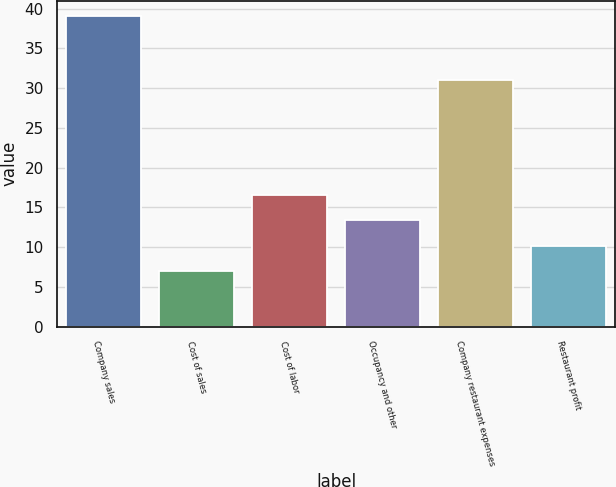<chart> <loc_0><loc_0><loc_500><loc_500><bar_chart><fcel>Company sales<fcel>Cost of sales<fcel>Cost of labor<fcel>Occupancy and other<fcel>Company restaurant expenses<fcel>Restaurant profit<nl><fcel>39<fcel>7<fcel>16.6<fcel>13.4<fcel>31<fcel>10.2<nl></chart> 